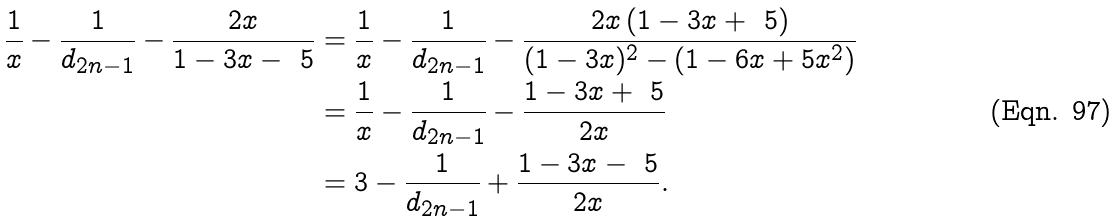Convert formula to latex. <formula><loc_0><loc_0><loc_500><loc_500>\frac { 1 } { x } - \frac { 1 } { d _ { 2 n - 1 } } - \frac { 2 x } { 1 - 3 x - \ 5 } & = \frac { 1 } { x } - \frac { 1 } { d _ { 2 n - 1 } } - \frac { 2 x \left ( 1 - 3 x + \ 5 \right ) } { ( 1 - 3 x ) ^ { 2 } - ( 1 - 6 x + 5 x ^ { 2 } ) } \\ & = \frac { 1 } { x } - \frac { 1 } { d _ { 2 n - 1 } } - \frac { 1 - 3 x + \ 5 } { 2 x } \\ & = 3 - \frac { 1 } { d _ { 2 n - 1 } } + \frac { 1 - 3 x - \ 5 } { 2 x } .</formula> 